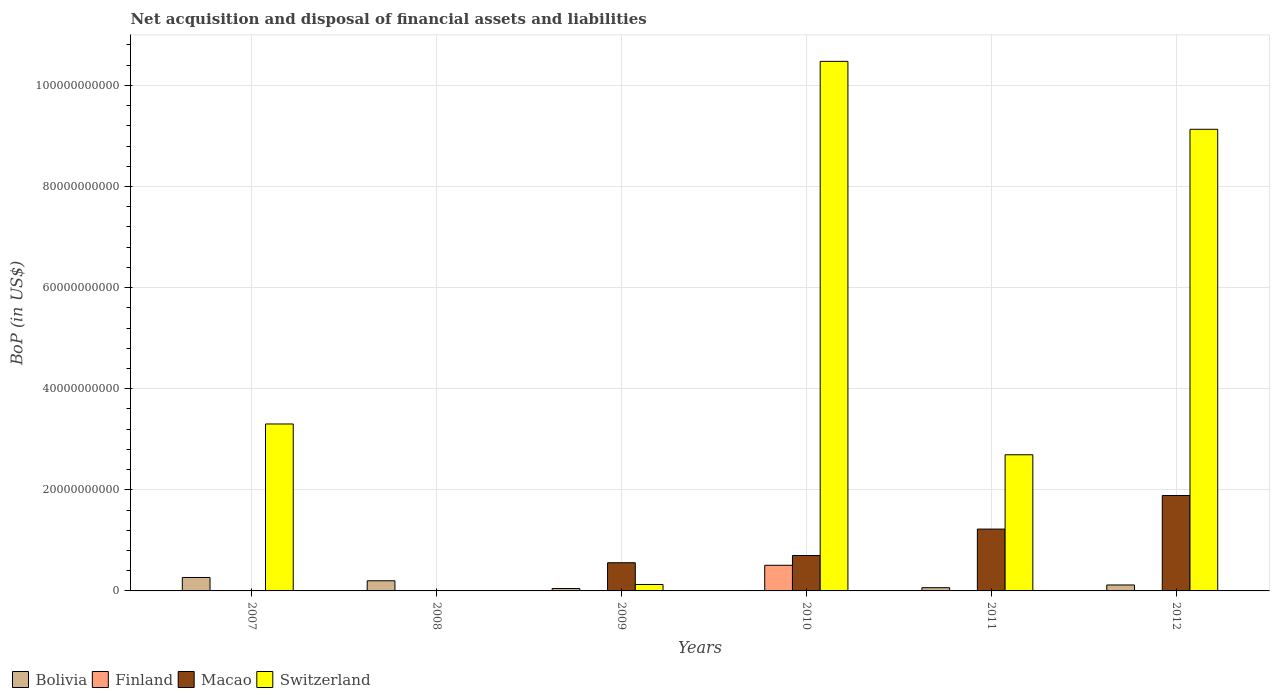How many different coloured bars are there?
Your response must be concise. 4. Are the number of bars per tick equal to the number of legend labels?
Provide a succinct answer. No. How many bars are there on the 3rd tick from the right?
Your response must be concise. 4. In how many cases, is the number of bars for a given year not equal to the number of legend labels?
Your answer should be very brief. 5. What is the Balance of Payments in Switzerland in 2012?
Ensure brevity in your answer.  9.13e+1. Across all years, what is the maximum Balance of Payments in Bolivia?
Provide a succinct answer. 2.66e+09. Across all years, what is the minimum Balance of Payments in Bolivia?
Give a very brief answer. 6.43e+07. In which year was the Balance of Payments in Bolivia maximum?
Offer a very short reply. 2007. What is the total Balance of Payments in Macao in the graph?
Give a very brief answer. 4.37e+1. What is the difference between the Balance of Payments in Switzerland in 2007 and that in 2012?
Offer a terse response. -5.83e+1. What is the difference between the Balance of Payments in Finland in 2010 and the Balance of Payments in Macao in 2009?
Your response must be concise. -5.06e+08. What is the average Balance of Payments in Switzerland per year?
Provide a succinct answer. 4.29e+1. In the year 2009, what is the difference between the Balance of Payments in Bolivia and Balance of Payments in Macao?
Provide a succinct answer. -5.11e+09. In how many years, is the Balance of Payments in Finland greater than 44000000000 US$?
Make the answer very short. 0. What is the ratio of the Balance of Payments in Bolivia in 2010 to that in 2012?
Provide a short and direct response. 0.05. Is the Balance of Payments in Switzerland in 2007 less than that in 2012?
Offer a very short reply. Yes. Is the difference between the Balance of Payments in Bolivia in 2010 and 2011 greater than the difference between the Balance of Payments in Macao in 2010 and 2011?
Keep it short and to the point. Yes. What is the difference between the highest and the second highest Balance of Payments in Switzerland?
Provide a succinct answer. 1.34e+1. What is the difference between the highest and the lowest Balance of Payments in Macao?
Give a very brief answer. 1.89e+1. Is it the case that in every year, the sum of the Balance of Payments in Macao and Balance of Payments in Switzerland is greater than the Balance of Payments in Bolivia?
Ensure brevity in your answer.  No. How many bars are there?
Ensure brevity in your answer.  16. What is the difference between two consecutive major ticks on the Y-axis?
Your response must be concise. 2.00e+1. Does the graph contain any zero values?
Your response must be concise. Yes. Does the graph contain grids?
Provide a short and direct response. Yes. How many legend labels are there?
Ensure brevity in your answer.  4. How are the legend labels stacked?
Offer a very short reply. Horizontal. What is the title of the graph?
Your answer should be very brief. Net acquisition and disposal of financial assets and liabilities. What is the label or title of the Y-axis?
Your response must be concise. BoP (in US$). What is the BoP (in US$) of Bolivia in 2007?
Provide a succinct answer. 2.66e+09. What is the BoP (in US$) of Finland in 2007?
Offer a very short reply. 0. What is the BoP (in US$) of Macao in 2007?
Offer a terse response. 0. What is the BoP (in US$) of Switzerland in 2007?
Your answer should be very brief. 3.30e+1. What is the BoP (in US$) of Bolivia in 2008?
Provide a short and direct response. 2.00e+09. What is the BoP (in US$) in Finland in 2008?
Ensure brevity in your answer.  0. What is the BoP (in US$) in Switzerland in 2008?
Offer a very short reply. 0. What is the BoP (in US$) in Bolivia in 2009?
Your response must be concise. 4.71e+08. What is the BoP (in US$) in Macao in 2009?
Offer a very short reply. 5.58e+09. What is the BoP (in US$) of Switzerland in 2009?
Keep it short and to the point. 1.28e+09. What is the BoP (in US$) in Bolivia in 2010?
Your response must be concise. 6.43e+07. What is the BoP (in US$) in Finland in 2010?
Offer a very short reply. 5.07e+09. What is the BoP (in US$) in Macao in 2010?
Your response must be concise. 7.01e+09. What is the BoP (in US$) of Switzerland in 2010?
Your answer should be very brief. 1.05e+11. What is the BoP (in US$) in Bolivia in 2011?
Your answer should be very brief. 6.38e+08. What is the BoP (in US$) of Macao in 2011?
Give a very brief answer. 1.22e+1. What is the BoP (in US$) of Switzerland in 2011?
Your answer should be very brief. 2.69e+1. What is the BoP (in US$) in Bolivia in 2012?
Keep it short and to the point. 1.18e+09. What is the BoP (in US$) in Finland in 2012?
Make the answer very short. 0. What is the BoP (in US$) in Macao in 2012?
Offer a very short reply. 1.89e+1. What is the BoP (in US$) in Switzerland in 2012?
Provide a short and direct response. 9.13e+1. Across all years, what is the maximum BoP (in US$) of Bolivia?
Your answer should be very brief. 2.66e+09. Across all years, what is the maximum BoP (in US$) in Finland?
Your answer should be very brief. 5.07e+09. Across all years, what is the maximum BoP (in US$) of Macao?
Provide a short and direct response. 1.89e+1. Across all years, what is the maximum BoP (in US$) in Switzerland?
Provide a short and direct response. 1.05e+11. Across all years, what is the minimum BoP (in US$) in Bolivia?
Your answer should be very brief. 6.43e+07. Across all years, what is the minimum BoP (in US$) of Switzerland?
Provide a short and direct response. 0. What is the total BoP (in US$) of Bolivia in the graph?
Your response must be concise. 7.01e+09. What is the total BoP (in US$) in Finland in the graph?
Your answer should be compact. 5.07e+09. What is the total BoP (in US$) in Macao in the graph?
Keep it short and to the point. 4.37e+1. What is the total BoP (in US$) of Switzerland in the graph?
Provide a short and direct response. 2.57e+11. What is the difference between the BoP (in US$) of Bolivia in 2007 and that in 2008?
Keep it short and to the point. 6.56e+08. What is the difference between the BoP (in US$) of Bolivia in 2007 and that in 2009?
Keep it short and to the point. 2.19e+09. What is the difference between the BoP (in US$) of Switzerland in 2007 and that in 2009?
Offer a terse response. 3.18e+1. What is the difference between the BoP (in US$) in Bolivia in 2007 and that in 2010?
Your answer should be very brief. 2.60e+09. What is the difference between the BoP (in US$) in Switzerland in 2007 and that in 2010?
Your response must be concise. -7.17e+1. What is the difference between the BoP (in US$) of Bolivia in 2007 and that in 2011?
Give a very brief answer. 2.02e+09. What is the difference between the BoP (in US$) of Switzerland in 2007 and that in 2011?
Make the answer very short. 6.09e+09. What is the difference between the BoP (in US$) in Bolivia in 2007 and that in 2012?
Give a very brief answer. 1.48e+09. What is the difference between the BoP (in US$) of Switzerland in 2007 and that in 2012?
Provide a short and direct response. -5.83e+1. What is the difference between the BoP (in US$) of Bolivia in 2008 and that in 2009?
Ensure brevity in your answer.  1.53e+09. What is the difference between the BoP (in US$) of Bolivia in 2008 and that in 2010?
Provide a short and direct response. 1.94e+09. What is the difference between the BoP (in US$) of Bolivia in 2008 and that in 2011?
Provide a succinct answer. 1.37e+09. What is the difference between the BoP (in US$) of Bolivia in 2008 and that in 2012?
Your answer should be compact. 8.28e+08. What is the difference between the BoP (in US$) of Bolivia in 2009 and that in 2010?
Keep it short and to the point. 4.06e+08. What is the difference between the BoP (in US$) of Macao in 2009 and that in 2010?
Your response must be concise. -1.43e+09. What is the difference between the BoP (in US$) in Switzerland in 2009 and that in 2010?
Your response must be concise. -1.03e+11. What is the difference between the BoP (in US$) in Bolivia in 2009 and that in 2011?
Give a very brief answer. -1.67e+08. What is the difference between the BoP (in US$) of Macao in 2009 and that in 2011?
Provide a succinct answer. -6.65e+09. What is the difference between the BoP (in US$) of Switzerland in 2009 and that in 2011?
Make the answer very short. -2.57e+1. What is the difference between the BoP (in US$) of Bolivia in 2009 and that in 2012?
Keep it short and to the point. -7.05e+08. What is the difference between the BoP (in US$) in Macao in 2009 and that in 2012?
Your answer should be compact. -1.33e+1. What is the difference between the BoP (in US$) in Switzerland in 2009 and that in 2012?
Ensure brevity in your answer.  -9.00e+1. What is the difference between the BoP (in US$) in Bolivia in 2010 and that in 2011?
Keep it short and to the point. -5.74e+08. What is the difference between the BoP (in US$) in Macao in 2010 and that in 2011?
Provide a succinct answer. -5.23e+09. What is the difference between the BoP (in US$) of Switzerland in 2010 and that in 2011?
Give a very brief answer. 7.78e+1. What is the difference between the BoP (in US$) of Bolivia in 2010 and that in 2012?
Your response must be concise. -1.11e+09. What is the difference between the BoP (in US$) of Macao in 2010 and that in 2012?
Your response must be concise. -1.19e+1. What is the difference between the BoP (in US$) of Switzerland in 2010 and that in 2012?
Make the answer very short. 1.34e+1. What is the difference between the BoP (in US$) in Bolivia in 2011 and that in 2012?
Your answer should be very brief. -5.38e+08. What is the difference between the BoP (in US$) of Macao in 2011 and that in 2012?
Your answer should be compact. -6.64e+09. What is the difference between the BoP (in US$) of Switzerland in 2011 and that in 2012?
Your answer should be compact. -6.44e+1. What is the difference between the BoP (in US$) of Bolivia in 2007 and the BoP (in US$) of Macao in 2009?
Offer a very short reply. -2.92e+09. What is the difference between the BoP (in US$) in Bolivia in 2007 and the BoP (in US$) in Switzerland in 2009?
Give a very brief answer. 1.38e+09. What is the difference between the BoP (in US$) in Bolivia in 2007 and the BoP (in US$) in Finland in 2010?
Keep it short and to the point. -2.41e+09. What is the difference between the BoP (in US$) of Bolivia in 2007 and the BoP (in US$) of Macao in 2010?
Provide a succinct answer. -4.35e+09. What is the difference between the BoP (in US$) of Bolivia in 2007 and the BoP (in US$) of Switzerland in 2010?
Keep it short and to the point. -1.02e+11. What is the difference between the BoP (in US$) in Bolivia in 2007 and the BoP (in US$) in Macao in 2011?
Ensure brevity in your answer.  -9.57e+09. What is the difference between the BoP (in US$) in Bolivia in 2007 and the BoP (in US$) in Switzerland in 2011?
Give a very brief answer. -2.43e+1. What is the difference between the BoP (in US$) of Bolivia in 2007 and the BoP (in US$) of Macao in 2012?
Give a very brief answer. -1.62e+1. What is the difference between the BoP (in US$) in Bolivia in 2007 and the BoP (in US$) in Switzerland in 2012?
Provide a succinct answer. -8.87e+1. What is the difference between the BoP (in US$) in Bolivia in 2008 and the BoP (in US$) in Macao in 2009?
Your response must be concise. -3.57e+09. What is the difference between the BoP (in US$) of Bolivia in 2008 and the BoP (in US$) of Switzerland in 2009?
Your answer should be compact. 7.29e+08. What is the difference between the BoP (in US$) in Bolivia in 2008 and the BoP (in US$) in Finland in 2010?
Give a very brief answer. -3.07e+09. What is the difference between the BoP (in US$) of Bolivia in 2008 and the BoP (in US$) of Macao in 2010?
Provide a succinct answer. -5.00e+09. What is the difference between the BoP (in US$) of Bolivia in 2008 and the BoP (in US$) of Switzerland in 2010?
Offer a very short reply. -1.03e+11. What is the difference between the BoP (in US$) in Bolivia in 2008 and the BoP (in US$) in Macao in 2011?
Give a very brief answer. -1.02e+1. What is the difference between the BoP (in US$) of Bolivia in 2008 and the BoP (in US$) of Switzerland in 2011?
Keep it short and to the point. -2.49e+1. What is the difference between the BoP (in US$) in Bolivia in 2008 and the BoP (in US$) in Macao in 2012?
Offer a very short reply. -1.69e+1. What is the difference between the BoP (in US$) in Bolivia in 2008 and the BoP (in US$) in Switzerland in 2012?
Ensure brevity in your answer.  -8.93e+1. What is the difference between the BoP (in US$) of Bolivia in 2009 and the BoP (in US$) of Finland in 2010?
Your answer should be compact. -4.60e+09. What is the difference between the BoP (in US$) of Bolivia in 2009 and the BoP (in US$) of Macao in 2010?
Give a very brief answer. -6.54e+09. What is the difference between the BoP (in US$) of Bolivia in 2009 and the BoP (in US$) of Switzerland in 2010?
Ensure brevity in your answer.  -1.04e+11. What is the difference between the BoP (in US$) in Macao in 2009 and the BoP (in US$) in Switzerland in 2010?
Keep it short and to the point. -9.92e+1. What is the difference between the BoP (in US$) in Bolivia in 2009 and the BoP (in US$) in Macao in 2011?
Offer a terse response. -1.18e+1. What is the difference between the BoP (in US$) of Bolivia in 2009 and the BoP (in US$) of Switzerland in 2011?
Provide a succinct answer. -2.65e+1. What is the difference between the BoP (in US$) of Macao in 2009 and the BoP (in US$) of Switzerland in 2011?
Ensure brevity in your answer.  -2.14e+1. What is the difference between the BoP (in US$) of Bolivia in 2009 and the BoP (in US$) of Macao in 2012?
Your response must be concise. -1.84e+1. What is the difference between the BoP (in US$) of Bolivia in 2009 and the BoP (in US$) of Switzerland in 2012?
Offer a terse response. -9.09e+1. What is the difference between the BoP (in US$) in Macao in 2009 and the BoP (in US$) in Switzerland in 2012?
Your answer should be compact. -8.57e+1. What is the difference between the BoP (in US$) of Bolivia in 2010 and the BoP (in US$) of Macao in 2011?
Offer a terse response. -1.22e+1. What is the difference between the BoP (in US$) of Bolivia in 2010 and the BoP (in US$) of Switzerland in 2011?
Provide a short and direct response. -2.69e+1. What is the difference between the BoP (in US$) in Finland in 2010 and the BoP (in US$) in Macao in 2011?
Offer a terse response. -7.16e+09. What is the difference between the BoP (in US$) of Finland in 2010 and the BoP (in US$) of Switzerland in 2011?
Make the answer very short. -2.19e+1. What is the difference between the BoP (in US$) in Macao in 2010 and the BoP (in US$) in Switzerland in 2011?
Make the answer very short. -1.99e+1. What is the difference between the BoP (in US$) of Bolivia in 2010 and the BoP (in US$) of Macao in 2012?
Offer a very short reply. -1.88e+1. What is the difference between the BoP (in US$) of Bolivia in 2010 and the BoP (in US$) of Switzerland in 2012?
Keep it short and to the point. -9.13e+1. What is the difference between the BoP (in US$) in Finland in 2010 and the BoP (in US$) in Macao in 2012?
Offer a very short reply. -1.38e+1. What is the difference between the BoP (in US$) of Finland in 2010 and the BoP (in US$) of Switzerland in 2012?
Your answer should be very brief. -8.62e+1. What is the difference between the BoP (in US$) of Macao in 2010 and the BoP (in US$) of Switzerland in 2012?
Ensure brevity in your answer.  -8.43e+1. What is the difference between the BoP (in US$) of Bolivia in 2011 and the BoP (in US$) of Macao in 2012?
Offer a terse response. -1.82e+1. What is the difference between the BoP (in US$) in Bolivia in 2011 and the BoP (in US$) in Switzerland in 2012?
Your answer should be compact. -9.07e+1. What is the difference between the BoP (in US$) in Macao in 2011 and the BoP (in US$) in Switzerland in 2012?
Make the answer very short. -7.91e+1. What is the average BoP (in US$) in Bolivia per year?
Keep it short and to the point. 1.17e+09. What is the average BoP (in US$) in Finland per year?
Keep it short and to the point. 8.45e+08. What is the average BoP (in US$) in Macao per year?
Your answer should be very brief. 7.28e+09. What is the average BoP (in US$) in Switzerland per year?
Give a very brief answer. 4.29e+1. In the year 2007, what is the difference between the BoP (in US$) in Bolivia and BoP (in US$) in Switzerland?
Offer a very short reply. -3.04e+1. In the year 2009, what is the difference between the BoP (in US$) in Bolivia and BoP (in US$) in Macao?
Your response must be concise. -5.11e+09. In the year 2009, what is the difference between the BoP (in US$) of Bolivia and BoP (in US$) of Switzerland?
Provide a succinct answer. -8.05e+08. In the year 2009, what is the difference between the BoP (in US$) in Macao and BoP (in US$) in Switzerland?
Your answer should be compact. 4.30e+09. In the year 2010, what is the difference between the BoP (in US$) in Bolivia and BoP (in US$) in Finland?
Keep it short and to the point. -5.01e+09. In the year 2010, what is the difference between the BoP (in US$) of Bolivia and BoP (in US$) of Macao?
Your response must be concise. -6.94e+09. In the year 2010, what is the difference between the BoP (in US$) in Bolivia and BoP (in US$) in Switzerland?
Offer a very short reply. -1.05e+11. In the year 2010, what is the difference between the BoP (in US$) in Finland and BoP (in US$) in Macao?
Provide a succinct answer. -1.93e+09. In the year 2010, what is the difference between the BoP (in US$) of Finland and BoP (in US$) of Switzerland?
Ensure brevity in your answer.  -9.97e+1. In the year 2010, what is the difference between the BoP (in US$) of Macao and BoP (in US$) of Switzerland?
Provide a succinct answer. -9.78e+1. In the year 2011, what is the difference between the BoP (in US$) of Bolivia and BoP (in US$) of Macao?
Keep it short and to the point. -1.16e+1. In the year 2011, what is the difference between the BoP (in US$) in Bolivia and BoP (in US$) in Switzerland?
Make the answer very short. -2.63e+1. In the year 2011, what is the difference between the BoP (in US$) in Macao and BoP (in US$) in Switzerland?
Your answer should be very brief. -1.47e+1. In the year 2012, what is the difference between the BoP (in US$) in Bolivia and BoP (in US$) in Macao?
Provide a succinct answer. -1.77e+1. In the year 2012, what is the difference between the BoP (in US$) in Bolivia and BoP (in US$) in Switzerland?
Keep it short and to the point. -9.01e+1. In the year 2012, what is the difference between the BoP (in US$) of Macao and BoP (in US$) of Switzerland?
Ensure brevity in your answer.  -7.24e+1. What is the ratio of the BoP (in US$) in Bolivia in 2007 to that in 2008?
Keep it short and to the point. 1.33. What is the ratio of the BoP (in US$) of Bolivia in 2007 to that in 2009?
Make the answer very short. 5.65. What is the ratio of the BoP (in US$) in Switzerland in 2007 to that in 2009?
Keep it short and to the point. 25.9. What is the ratio of the BoP (in US$) in Bolivia in 2007 to that in 2010?
Your answer should be compact. 41.38. What is the ratio of the BoP (in US$) of Switzerland in 2007 to that in 2010?
Provide a succinct answer. 0.32. What is the ratio of the BoP (in US$) in Bolivia in 2007 to that in 2011?
Keep it short and to the point. 4.17. What is the ratio of the BoP (in US$) of Switzerland in 2007 to that in 2011?
Provide a succinct answer. 1.23. What is the ratio of the BoP (in US$) in Bolivia in 2007 to that in 2012?
Offer a very short reply. 2.26. What is the ratio of the BoP (in US$) in Switzerland in 2007 to that in 2012?
Make the answer very short. 0.36. What is the ratio of the BoP (in US$) in Bolivia in 2008 to that in 2009?
Keep it short and to the point. 4.26. What is the ratio of the BoP (in US$) in Bolivia in 2008 to that in 2010?
Give a very brief answer. 31.17. What is the ratio of the BoP (in US$) in Bolivia in 2008 to that in 2011?
Your answer should be compact. 3.14. What is the ratio of the BoP (in US$) in Bolivia in 2008 to that in 2012?
Provide a short and direct response. 1.7. What is the ratio of the BoP (in US$) of Bolivia in 2009 to that in 2010?
Your answer should be very brief. 7.32. What is the ratio of the BoP (in US$) in Macao in 2009 to that in 2010?
Your response must be concise. 0.8. What is the ratio of the BoP (in US$) of Switzerland in 2009 to that in 2010?
Offer a very short reply. 0.01. What is the ratio of the BoP (in US$) in Bolivia in 2009 to that in 2011?
Offer a terse response. 0.74. What is the ratio of the BoP (in US$) in Macao in 2009 to that in 2011?
Provide a succinct answer. 0.46. What is the ratio of the BoP (in US$) in Switzerland in 2009 to that in 2011?
Make the answer very short. 0.05. What is the ratio of the BoP (in US$) of Bolivia in 2009 to that in 2012?
Your answer should be compact. 0.4. What is the ratio of the BoP (in US$) in Macao in 2009 to that in 2012?
Offer a very short reply. 0.3. What is the ratio of the BoP (in US$) in Switzerland in 2009 to that in 2012?
Your response must be concise. 0.01. What is the ratio of the BoP (in US$) of Bolivia in 2010 to that in 2011?
Offer a very short reply. 0.1. What is the ratio of the BoP (in US$) of Macao in 2010 to that in 2011?
Your answer should be very brief. 0.57. What is the ratio of the BoP (in US$) in Switzerland in 2010 to that in 2011?
Ensure brevity in your answer.  3.89. What is the ratio of the BoP (in US$) in Bolivia in 2010 to that in 2012?
Provide a succinct answer. 0.05. What is the ratio of the BoP (in US$) in Macao in 2010 to that in 2012?
Provide a succinct answer. 0.37. What is the ratio of the BoP (in US$) of Switzerland in 2010 to that in 2012?
Keep it short and to the point. 1.15. What is the ratio of the BoP (in US$) of Bolivia in 2011 to that in 2012?
Ensure brevity in your answer.  0.54. What is the ratio of the BoP (in US$) of Macao in 2011 to that in 2012?
Your answer should be very brief. 0.65. What is the ratio of the BoP (in US$) of Switzerland in 2011 to that in 2012?
Give a very brief answer. 0.29. What is the difference between the highest and the second highest BoP (in US$) in Bolivia?
Your response must be concise. 6.56e+08. What is the difference between the highest and the second highest BoP (in US$) of Macao?
Keep it short and to the point. 6.64e+09. What is the difference between the highest and the second highest BoP (in US$) of Switzerland?
Keep it short and to the point. 1.34e+1. What is the difference between the highest and the lowest BoP (in US$) in Bolivia?
Keep it short and to the point. 2.60e+09. What is the difference between the highest and the lowest BoP (in US$) in Finland?
Keep it short and to the point. 5.07e+09. What is the difference between the highest and the lowest BoP (in US$) of Macao?
Your answer should be compact. 1.89e+1. What is the difference between the highest and the lowest BoP (in US$) in Switzerland?
Provide a short and direct response. 1.05e+11. 